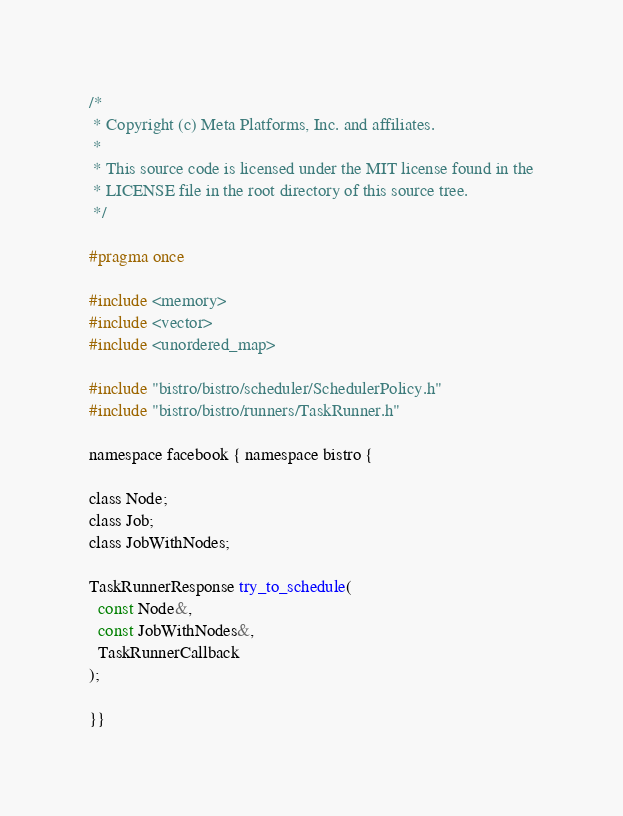<code> <loc_0><loc_0><loc_500><loc_500><_C_>/*
 * Copyright (c) Meta Platforms, Inc. and affiliates.
 *
 * This source code is licensed under the MIT license found in the
 * LICENSE file in the root directory of this source tree.
 */

#pragma once

#include <memory>
#include <vector>
#include <unordered_map>

#include "bistro/bistro/scheduler/SchedulerPolicy.h"
#include "bistro/bistro/runners/TaskRunner.h"

namespace facebook { namespace bistro {

class Node;
class Job;
class JobWithNodes;

TaskRunnerResponse try_to_schedule(
  const Node&,
  const JobWithNodes&,
  TaskRunnerCallback
);

}}
</code> 